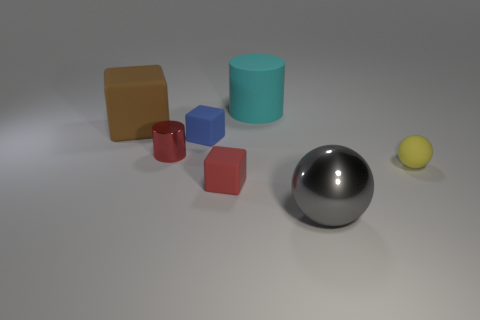The cylinder that is in front of the tiny blue rubber object is what color? The cylinder in front of the small blue cube is a shade of teal, exhibiting a soft, muted blend of blue and green tones, creating a calming effect in the image. 